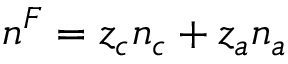<formula> <loc_0><loc_0><loc_500><loc_500>n ^ { F } = z _ { c } n _ { c } + z _ { a } n _ { a }</formula> 